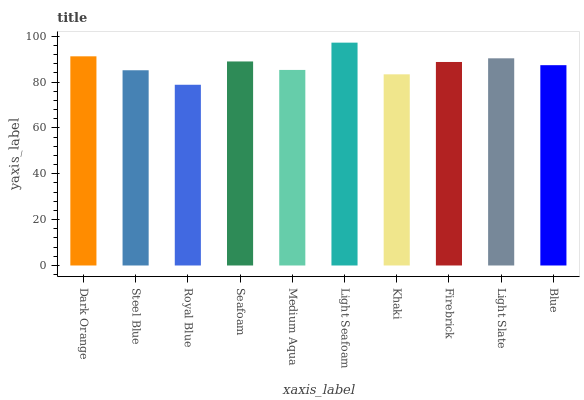Is Royal Blue the minimum?
Answer yes or no. Yes. Is Light Seafoam the maximum?
Answer yes or no. Yes. Is Steel Blue the minimum?
Answer yes or no. No. Is Steel Blue the maximum?
Answer yes or no. No. Is Dark Orange greater than Steel Blue?
Answer yes or no. Yes. Is Steel Blue less than Dark Orange?
Answer yes or no. Yes. Is Steel Blue greater than Dark Orange?
Answer yes or no. No. Is Dark Orange less than Steel Blue?
Answer yes or no. No. Is Firebrick the high median?
Answer yes or no. Yes. Is Blue the low median?
Answer yes or no. Yes. Is Light Seafoam the high median?
Answer yes or no. No. Is Steel Blue the low median?
Answer yes or no. No. 